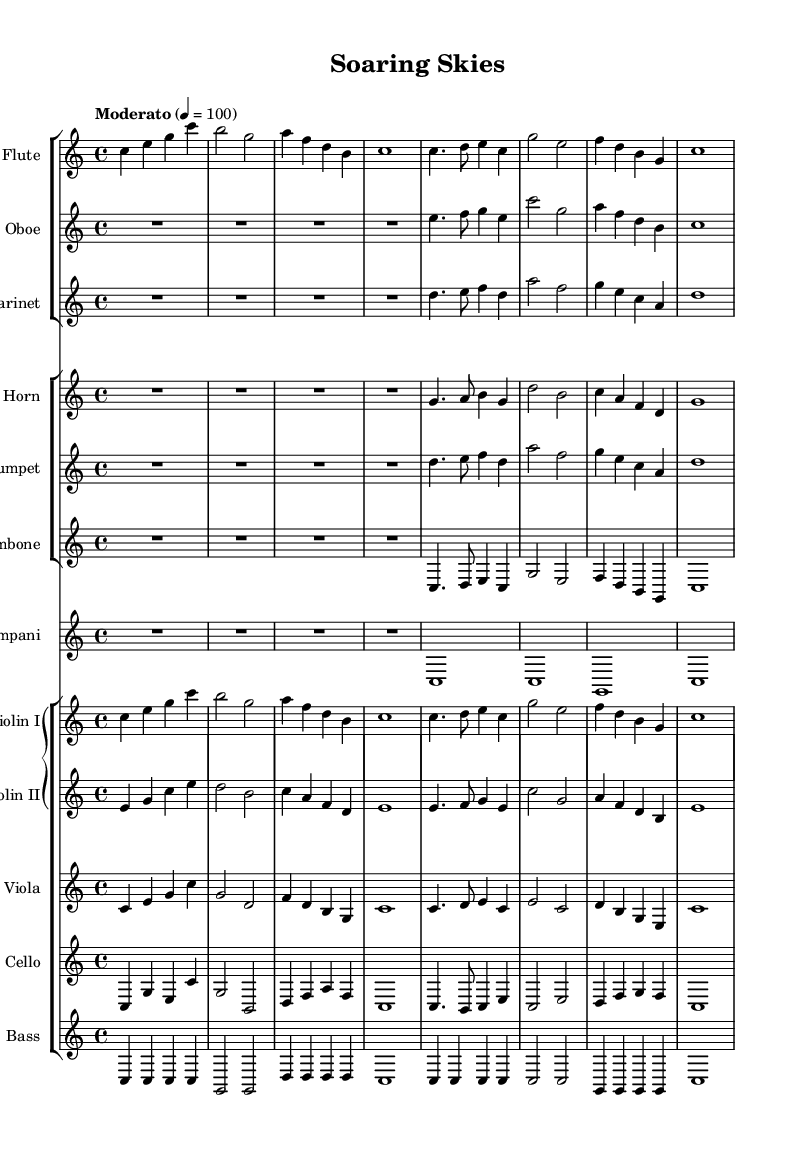What is the key signature of this music? The key signature is C major, which has no sharps or flats indicated at the beginning of the staff.
Answer: C major What is the time signature of the piece? The time signature is indicated by the numbers at the beginning, which state that there are four beats per measure with a quarter note getting one beat.
Answer: 4/4 What is the tempo marking for this composition? The tempo marking indicates a moderate speed, specified as 'Moderato' at 100 beats per minute.
Answer: Moderato Which instruments are playing the melody in the first section? The melody in the first section is primarily carried by the flute, violins, and oboe, as indicated by their respective staves containing the main thematic material.
Answer: Flute, Violins, Oboe How many measures are in the first system of the score? Counting the measures in the first system, there are a total of four measures, which are clearly delineated by bar lines.
Answer: 4 How does the harmony in the brass section contribute to the theme of flight? The brass section, particularly the Horn, Trumpet, and Trombone, creates a rich harmonic texture that evokes the soaring sensation associated with flight, complementing the melodic lines and enhancing the overall feeling of elevation and movement.
Answer: Rich harmonic texture What instruments provide the rhythmic foundation in this orchestral piece? The rhythmic foundation is primarily provided by the Timpani and Bass, which play sustained notes and support the harmonic and melodic content, creating depth and stability in the overall ensemble.
Answer: Timpani, Bass 